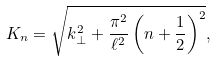Convert formula to latex. <formula><loc_0><loc_0><loc_500><loc_500>K _ { n } = \sqrt { k _ { \bot } ^ { 2 } + \frac { \pi ^ { 2 } } { \ell ^ { 2 } } \left ( n + \frac { 1 } { 2 } \right ) ^ { 2 } } ,</formula> 